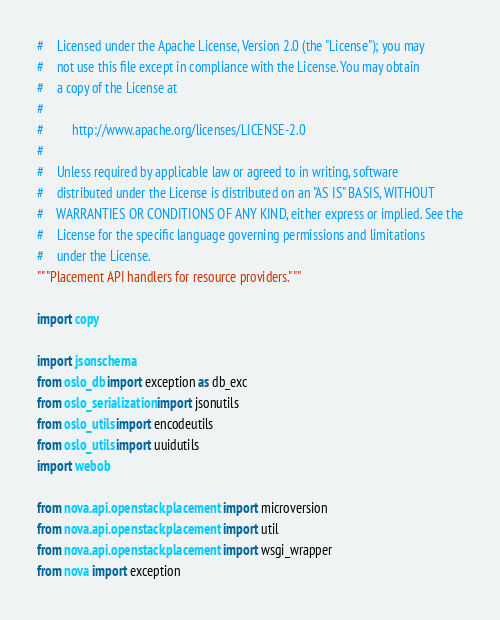<code> <loc_0><loc_0><loc_500><loc_500><_Python_>#    Licensed under the Apache License, Version 2.0 (the "License"); you may
#    not use this file except in compliance with the License. You may obtain
#    a copy of the License at
#
#         http://www.apache.org/licenses/LICENSE-2.0
#
#    Unless required by applicable law or agreed to in writing, software
#    distributed under the License is distributed on an "AS IS" BASIS, WITHOUT
#    WARRANTIES OR CONDITIONS OF ANY KIND, either express or implied. See the
#    License for the specific language governing permissions and limitations
#    under the License.
"""Placement API handlers for resource providers."""

import copy

import jsonschema
from oslo_db import exception as db_exc
from oslo_serialization import jsonutils
from oslo_utils import encodeutils
from oslo_utils import uuidutils
import webob

from nova.api.openstack.placement import microversion
from nova.api.openstack.placement import util
from nova.api.openstack.placement import wsgi_wrapper
from nova import exception</code> 